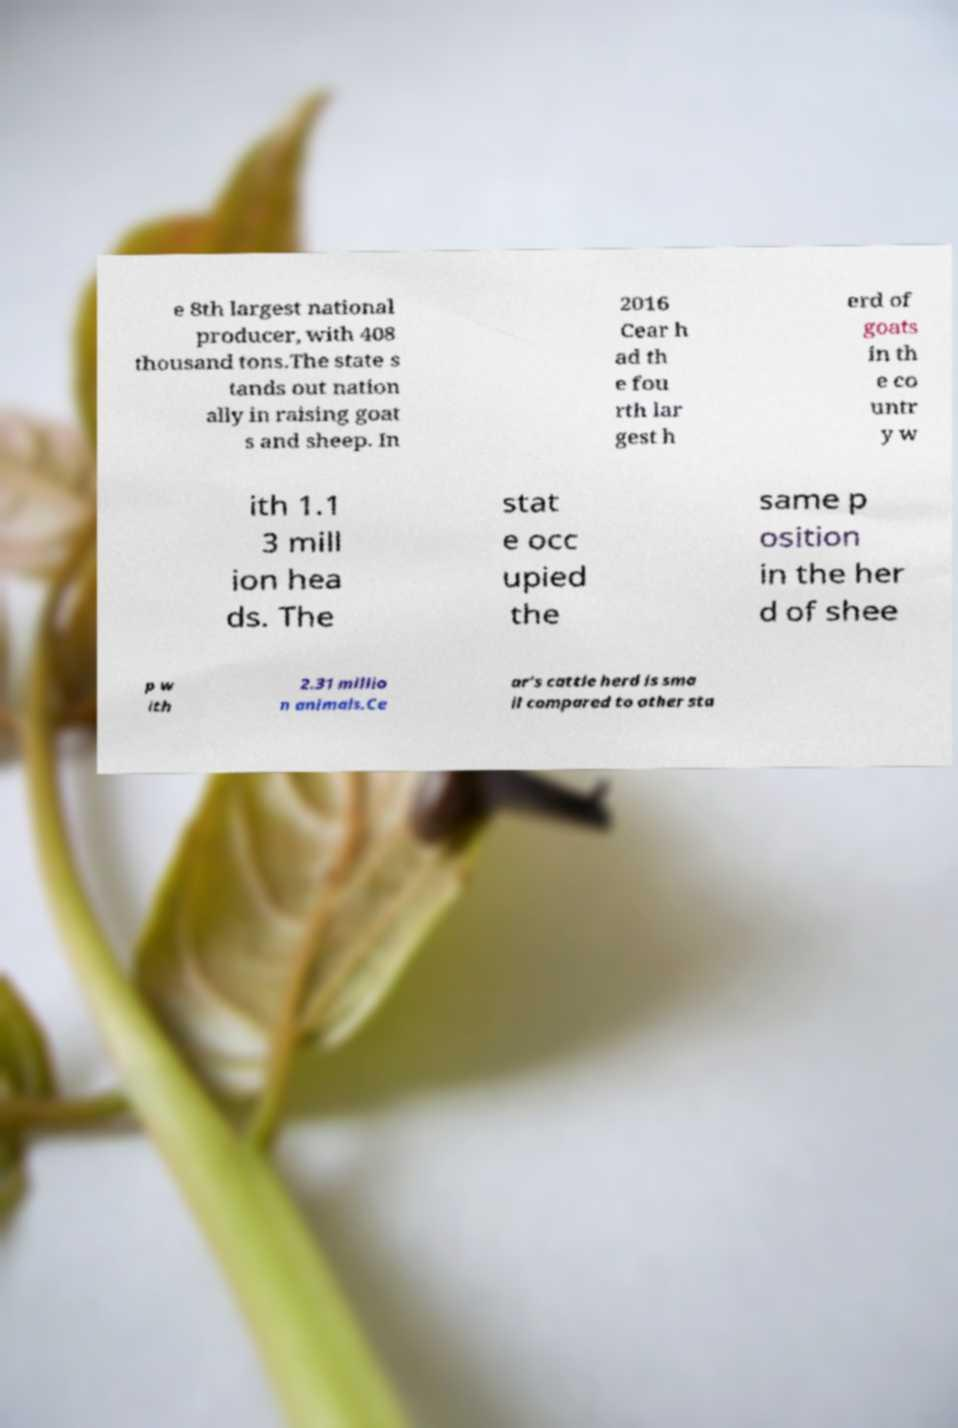What messages or text are displayed in this image? I need them in a readable, typed format. e 8th largest national producer, with 408 thousand tons.The state s tands out nation ally in raising goat s and sheep. In 2016 Cear h ad th e fou rth lar gest h erd of goats in th e co untr y w ith 1.1 3 mill ion hea ds. The stat e occ upied the same p osition in the her d of shee p w ith 2.31 millio n animals.Ce ar's cattle herd is sma ll compared to other sta 